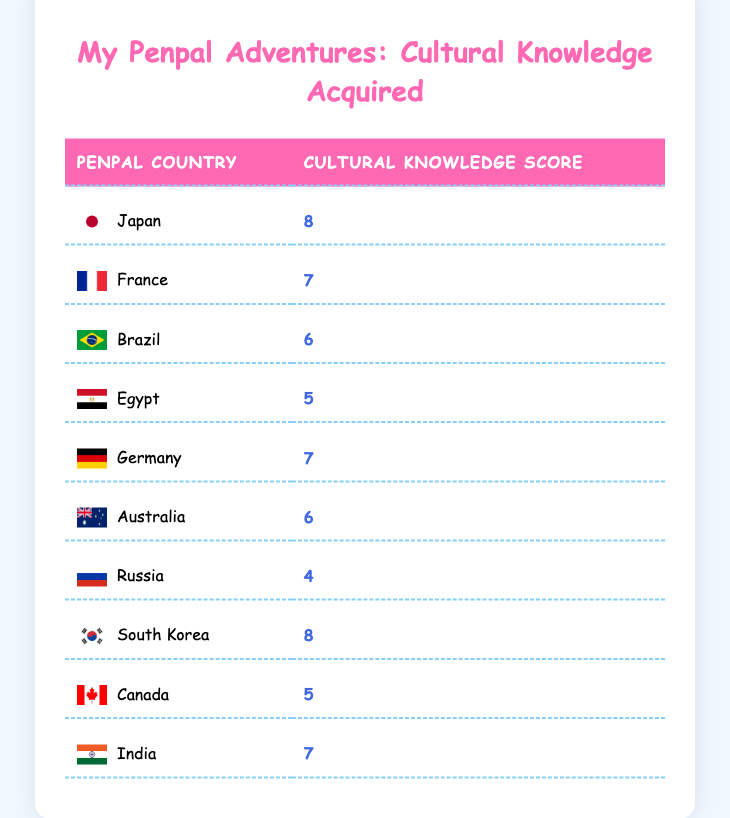What country has the highest cultural knowledge score? Looking at the cultural knowledge scores listed in the table, Japan and South Korea both have scores of 8, which are the highest scores among all entries.
Answer: Japan and South Korea What is the cultural knowledge score for Canada? Canada is listed in the table with a cultural knowledge score of 5.
Answer: 5 How many countries have a cultural knowledge score of 7? The countries with a cultural knowledge score of 7 are France, Germany, and India. There are 3 such countries.
Answer: 3 Which country has the lowest cultural knowledge score? By examining the table, Russia has the lowest cultural knowledge score of 4 among all the countries.
Answer: Russia What is the average cultural knowledge score of all the countries? To find the average, add up all the cultural knowledge scores: 8 + 7 + 6 + 5 + 7 + 6 + 4 + 8 + 5 + 7 = 63. There are 10 countries, so the average is 63 / 10 = 6.3.
Answer: 6.3 Is there a country that has both a cultural knowledge score of 8 and is located in Asia? Yes, both Japan and South Korea have cultural knowledge scores of 8 and are located in Asia.
Answer: Yes Which two countries have a cultural knowledge score difference of 3? From the table, Germany (7) and Russia (4) have a difference of 3 in their cultural knowledge scores, as 7 - 4 = 3.
Answer: Germany and Russia If you were to compare countries with scores above 6, how many would there be? The countries with scores above 6 are Japan (8), South Korea (8), France (7), Germany (7), and India (7). Counting these gives a total of 5 countries.
Answer: 5 What is the sum of cultural knowledge scores for countries in Europe? The European countries listed are France (7), Germany (7), and Russia (4). Adding their scores gives 7 + 7 + 4 = 18.
Answer: 18 